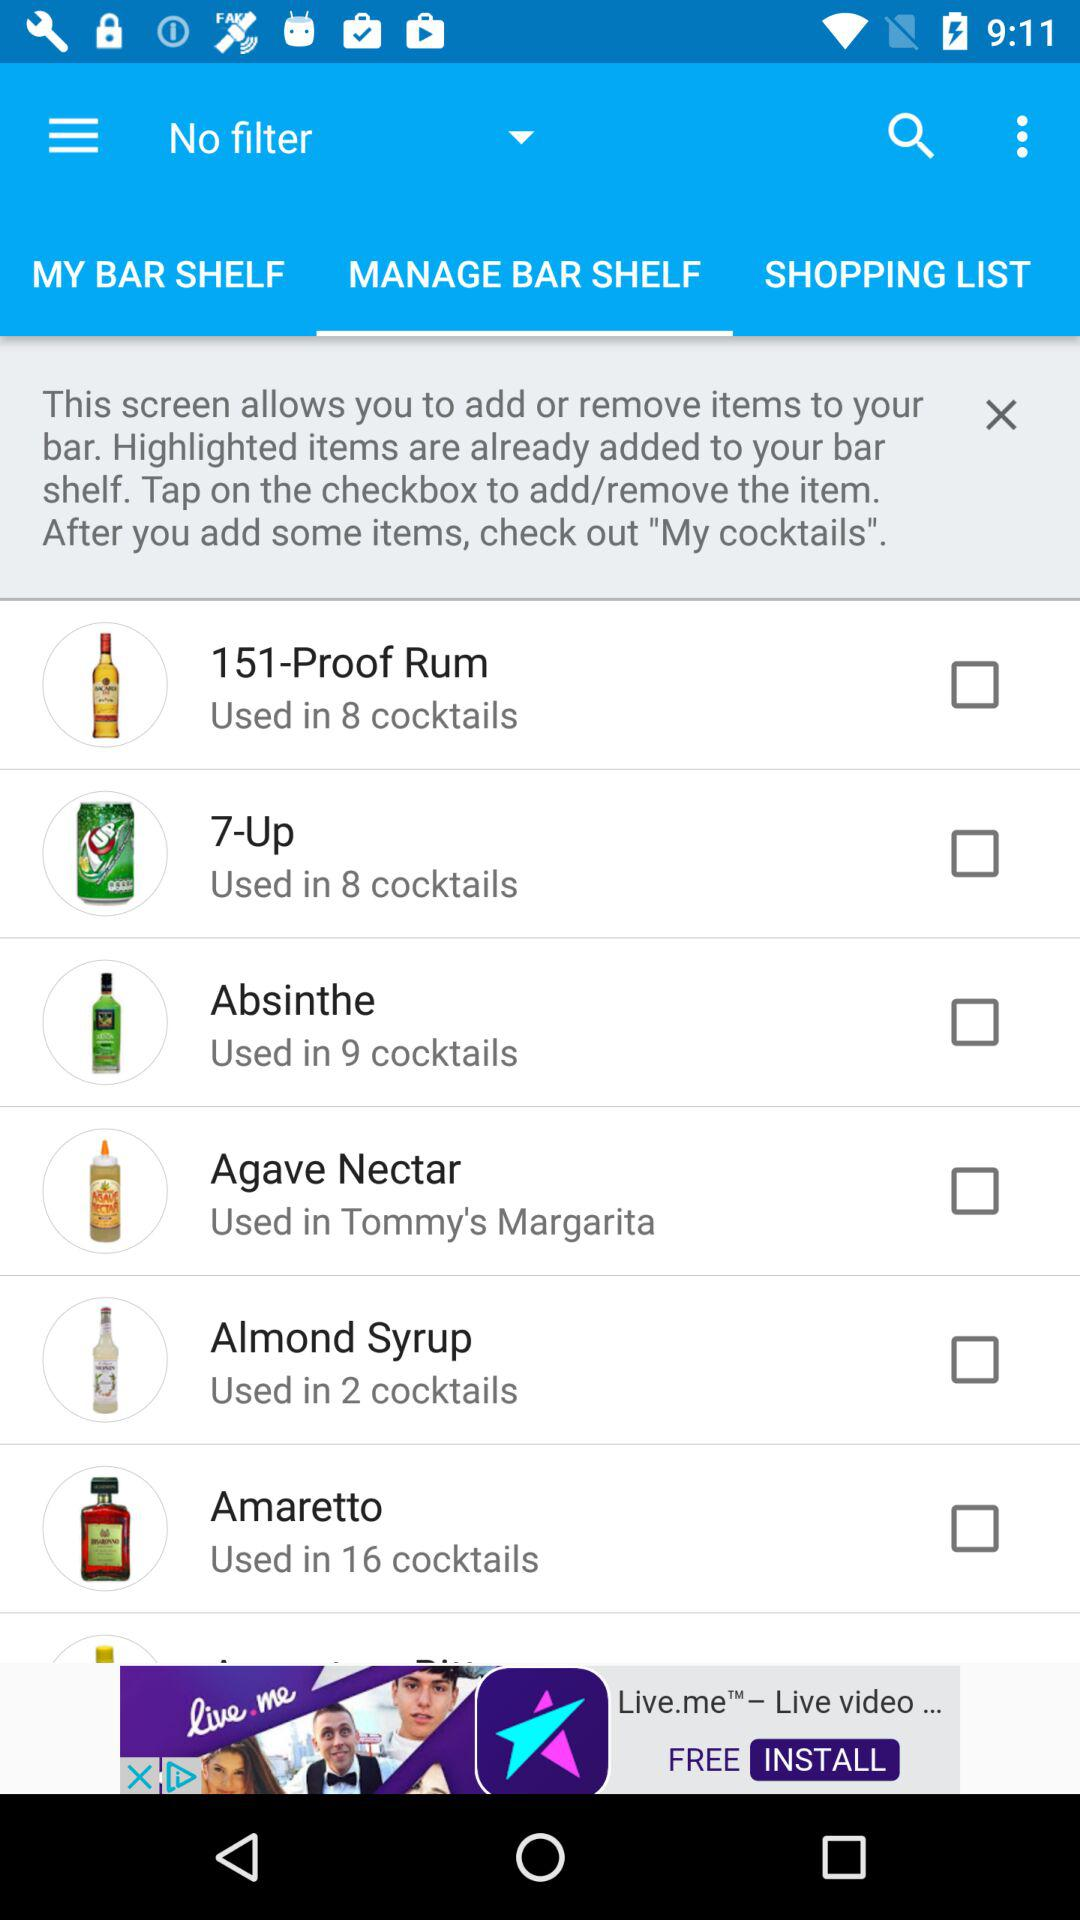What is the total number of cocktails that contain amaretto? There are 16 cocktails that contain amaretto. 